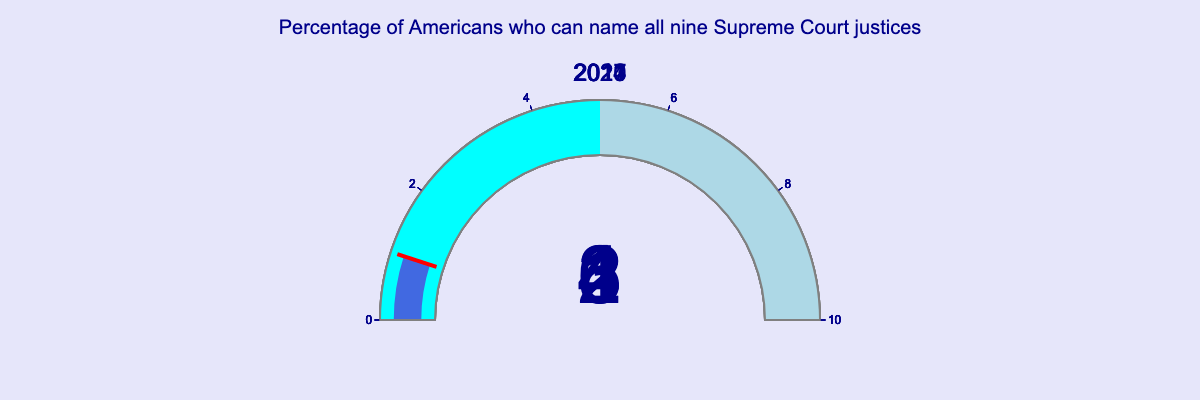What is the title of the figure? The title is written at the top center of the figure in a large font, making it prominent.
Answer: Percentage of Americans who can name all nine Supreme Court justices How many years' data are displayed in the figure? By counting the number of gauges, each representing a different year, we can determine the number of years presented in the figure.
Answer: 5 What is the percentage of Americans who could name all nine Supreme Court justices in 2023? Look at the gauge that shows the value for the year 2023; it displays the number clearly.
Answer: 4 In which year was the percentage of Americans who could name all nine Supreme Court justices the lowest? Compare the values on each gauge to find the smallest percentage.
Answer: 2011 What is the difference in the percentage of Americans who could name all nine Supreme Court justices between 2014 and 2023? Subtract the percentage in 2014 from the percentage in 2023 (4 - 2).
Answer: 2 Which year saw the highest percentage of Americans who could name all nine Supreme Court justices? Compare the percentages on all gauges to find the highest value.
Answer: 2020 What is the average percentage of Americans who could name all nine Supreme Court justices from 2011 to 2023? Sum all the percentages and divide by the number of years (1+2+3+6+4)/5. (1 + 2 + 3 + 6 + 4) = 16, 16/5 = 3.2
Answer: 3.2 Does any year have a percentage above 5%? Check each gauge to see if any of the values exceed 5; only the gauge for 2020 does.
Answer: Yes, 2020 Which range of colors represents the values 0 to 5 in the gauges? Identify the color used for the lower range of each gauge.
Answer: Cyan What is the color of the bar showing the percentage value in each gauge? Observe the bar indicating the percentage value in each gauge; it is consistently colored.
Answer: Royal blue 